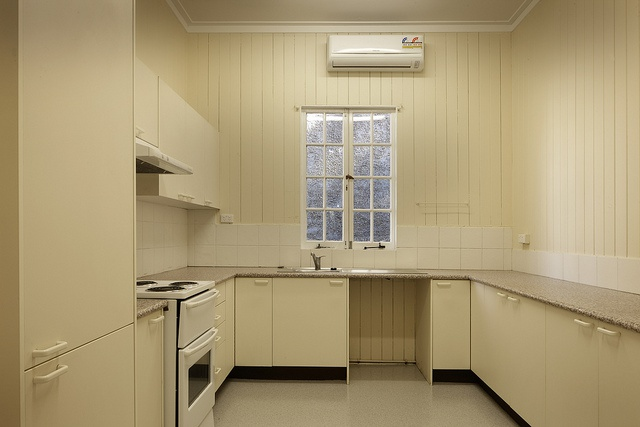Describe the objects in this image and their specific colors. I can see oven in olive, tan, black, and gray tones, sink in olive, tan, gray, and beige tones, and sink in olive, tan, and lightgray tones in this image. 